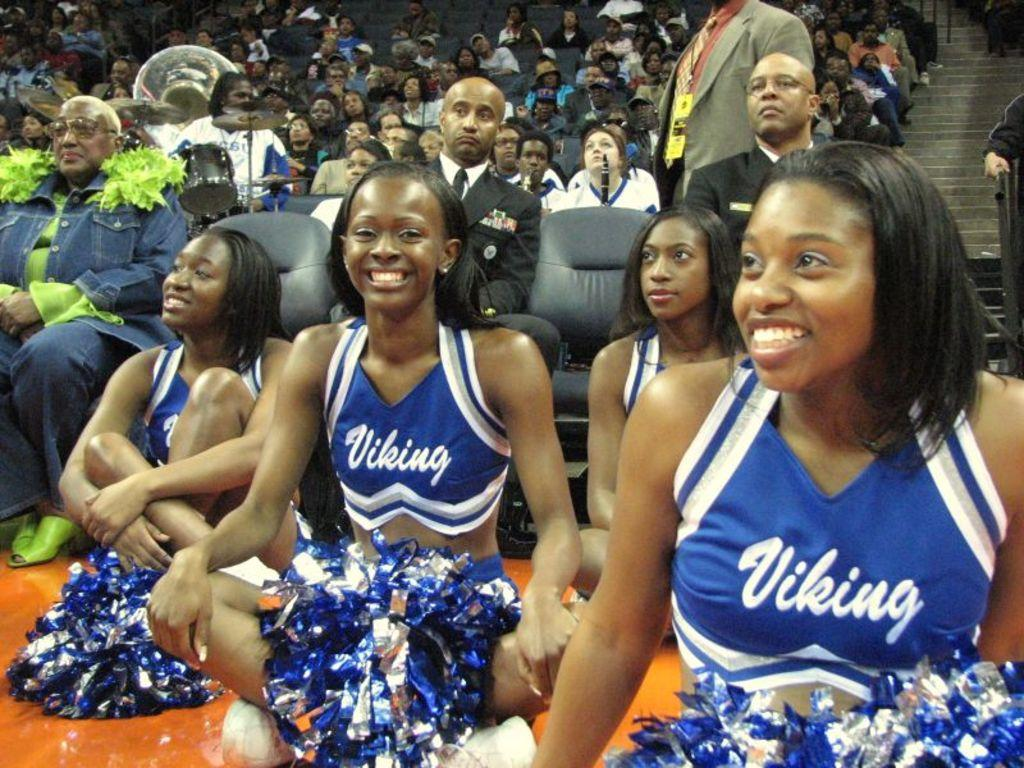<image>
Render a clear and concise summary of the photo. Four black Viking cheerleaders sitting on the floor of an arena. 